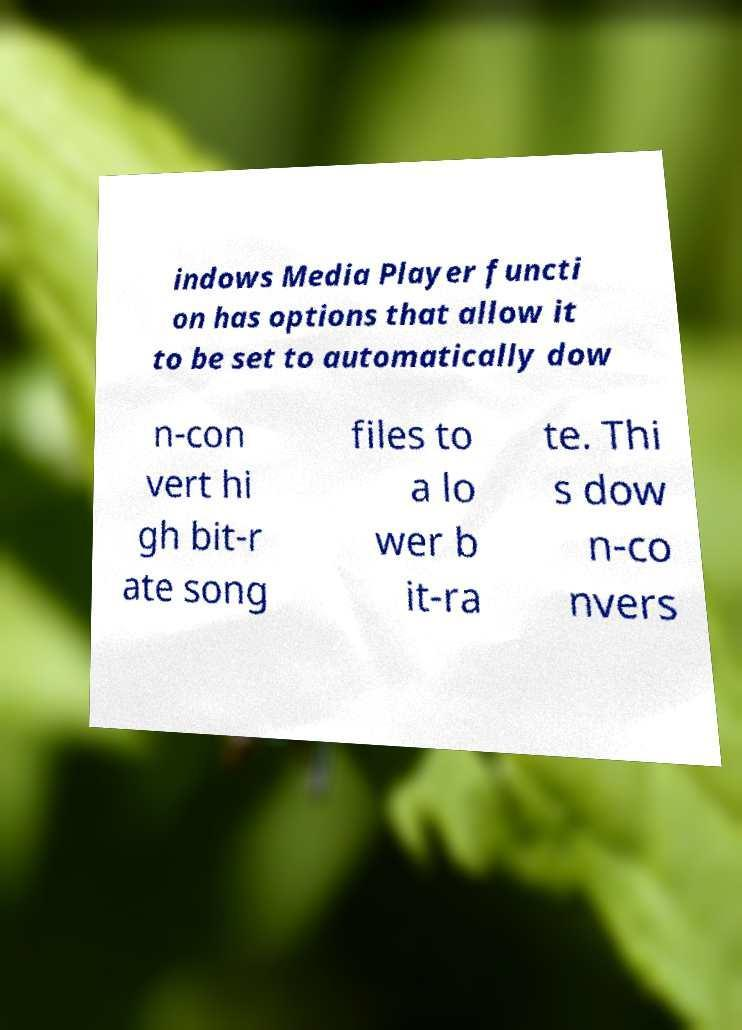Could you assist in decoding the text presented in this image and type it out clearly? indows Media Player functi on has options that allow it to be set to automatically dow n-con vert hi gh bit-r ate song files to a lo wer b it-ra te. Thi s dow n-co nvers 